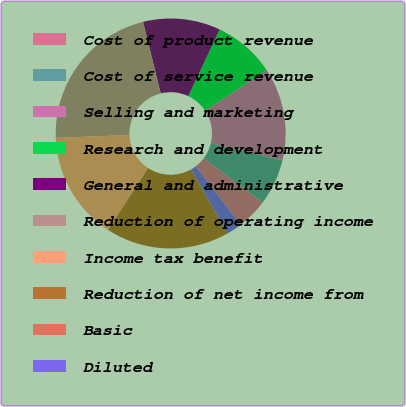Convert chart to OTSL. <chart><loc_0><loc_0><loc_500><loc_500><pie_chart><fcel>Cost of product revenue<fcel>Cost of service revenue<fcel>Selling and marketing<fcel>Research and development<fcel>General and administrative<fcel>Reduction of operating income<fcel>Income tax benefit<fcel>Reduction of net income from<fcel>Basic<fcel>Diluted<nl><fcel>4.35%<fcel>6.52%<fcel>13.04%<fcel>8.7%<fcel>10.87%<fcel>21.74%<fcel>15.22%<fcel>17.39%<fcel>0.0%<fcel>2.17%<nl></chart> 